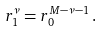<formula> <loc_0><loc_0><loc_500><loc_500>r _ { 1 } ^ { \nu } = r _ { 0 } ^ { M - \nu - 1 } \, .</formula> 